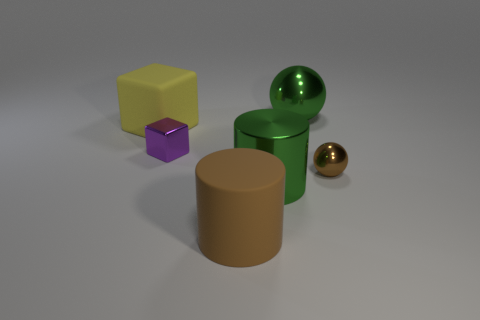Aside from the spheres, what other three-dimensional shapes are present in the image? Aside from the spheres, the image features a large brown cylinder and a smaller purple cube, adding a variety of three-dimensional geometric forms to the scene. 